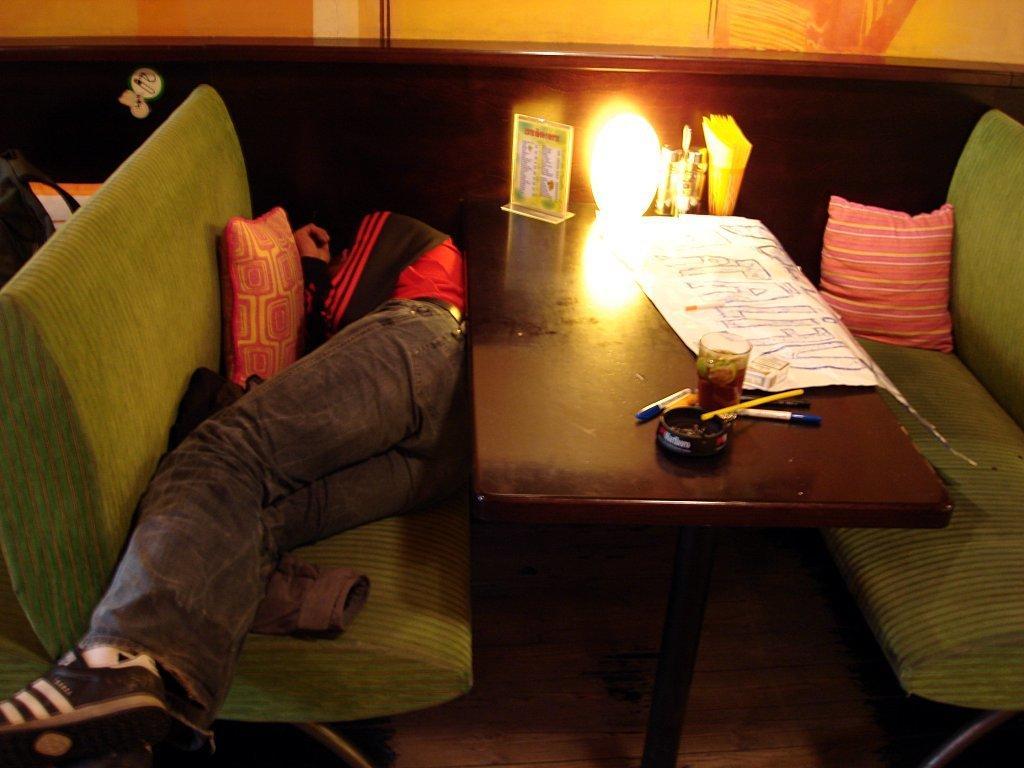Please provide a concise description of this image. On the left we can see one person lying on the couch. Beside him there is a table,on table we can see chart,light,glass,pens and paper. In the background there is a wood wall,couch and pillow. 